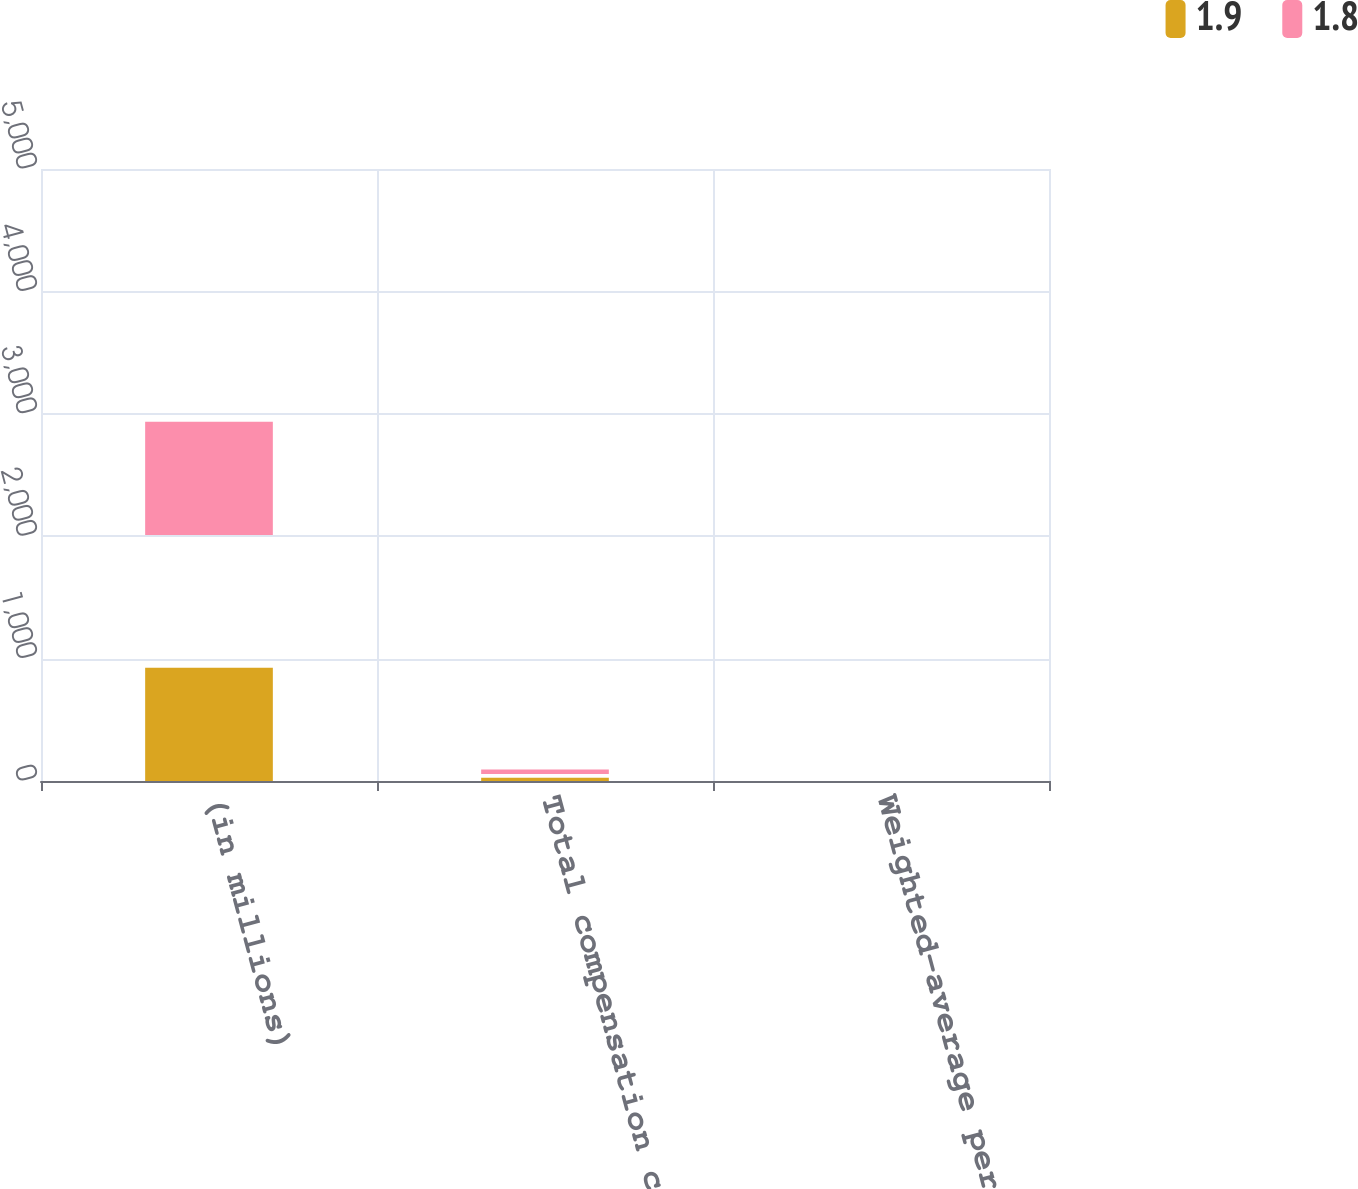Convert chart to OTSL. <chart><loc_0><loc_0><loc_500><loc_500><stacked_bar_chart><ecel><fcel>(in millions)<fcel>Total compensation cost net of<fcel>Weighted-average period in<nl><fcel>1.9<fcel>2010<fcel>57.5<fcel>1.8<nl><fcel>1.8<fcel>2008<fcel>80.8<fcel>1.9<nl></chart> 